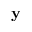<formula> <loc_0><loc_0><loc_500><loc_500>y</formula> 